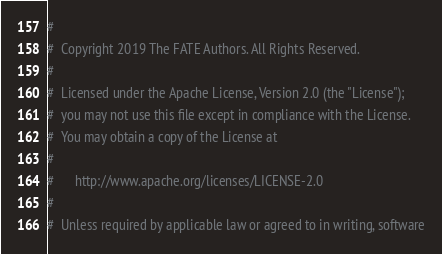<code> <loc_0><loc_0><loc_500><loc_500><_Python_>#
#  Copyright 2019 The FATE Authors. All Rights Reserved.
#
#  Licensed under the Apache License, Version 2.0 (the "License");
#  you may not use this file except in compliance with the License.
#  You may obtain a copy of the License at
#
#      http://www.apache.org/licenses/LICENSE-2.0
#
#  Unless required by applicable law or agreed to in writing, software</code> 